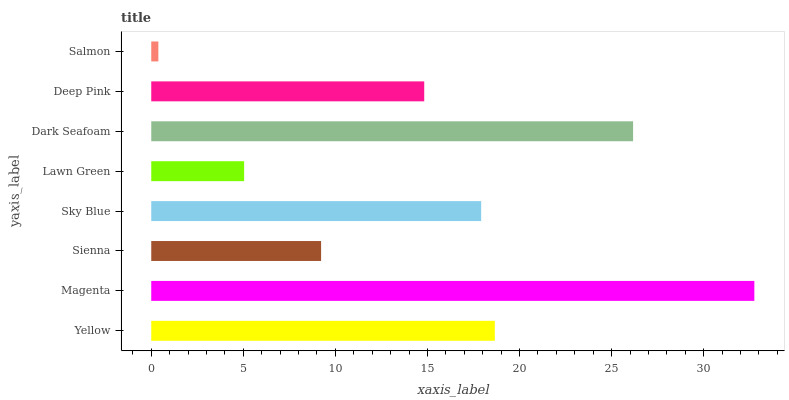Is Salmon the minimum?
Answer yes or no. Yes. Is Magenta the maximum?
Answer yes or no. Yes. Is Sienna the minimum?
Answer yes or no. No. Is Sienna the maximum?
Answer yes or no. No. Is Magenta greater than Sienna?
Answer yes or no. Yes. Is Sienna less than Magenta?
Answer yes or no. Yes. Is Sienna greater than Magenta?
Answer yes or no. No. Is Magenta less than Sienna?
Answer yes or no. No. Is Sky Blue the high median?
Answer yes or no. Yes. Is Deep Pink the low median?
Answer yes or no. Yes. Is Magenta the high median?
Answer yes or no. No. Is Sienna the low median?
Answer yes or no. No. 